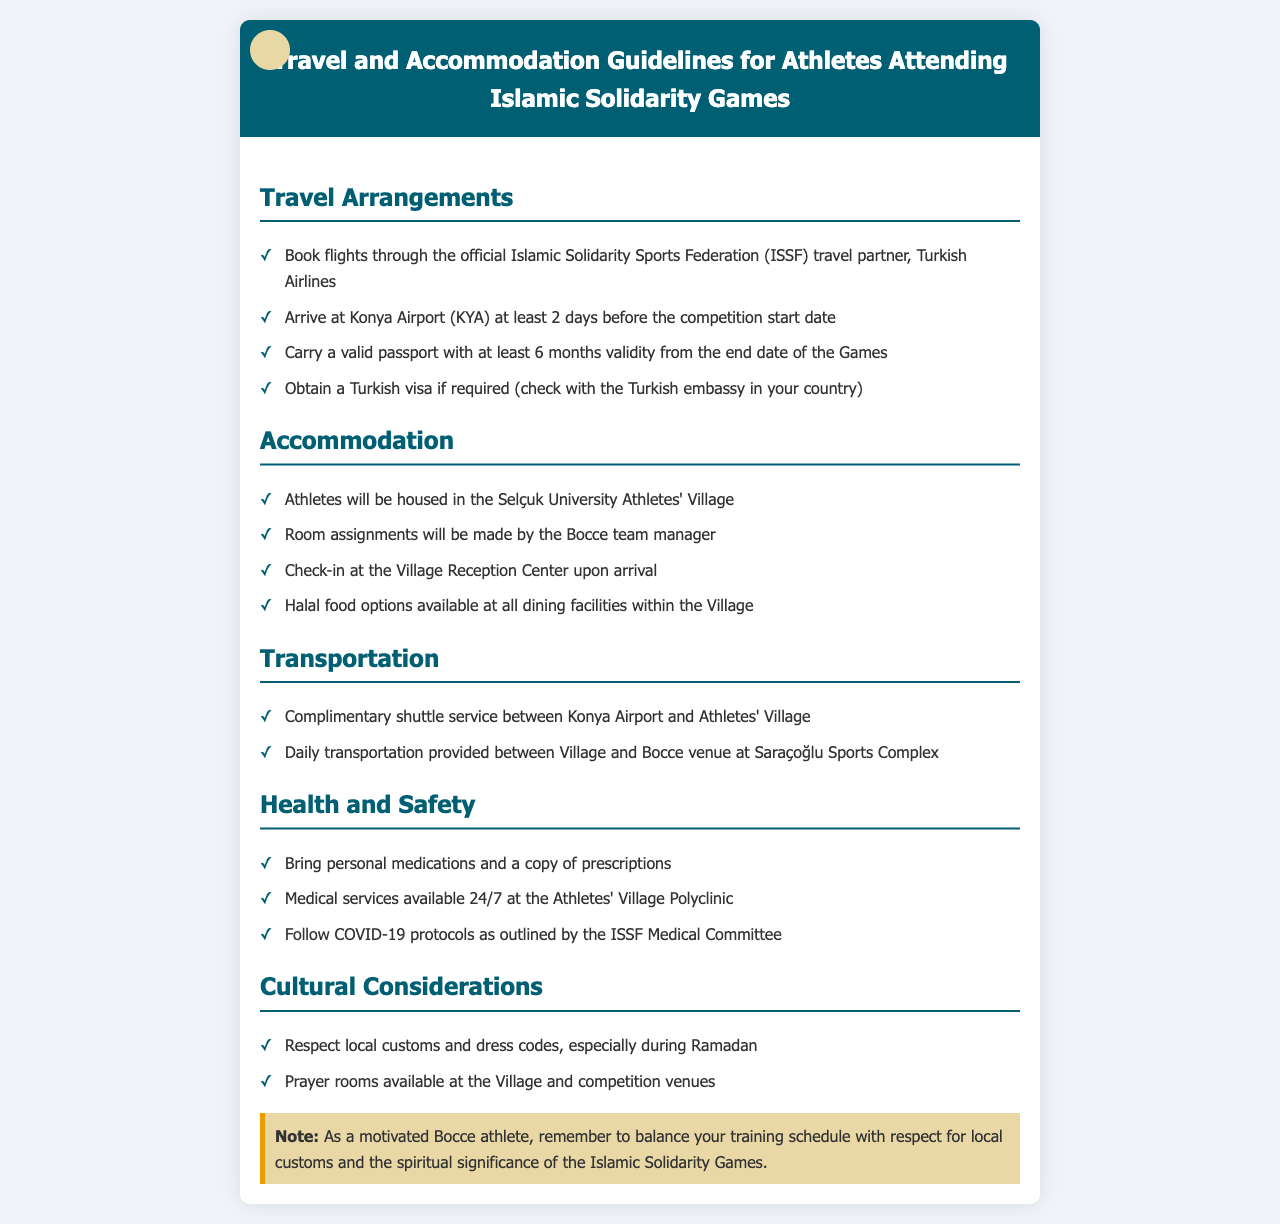What is the official travel partner for booking flights? The official travel partner for booking flights is Turkish Airlines.
Answer: Turkish Airlines How many days before the competition should athletes arrive? Athletes should arrive at least 2 days before the competition start date.
Answer: 2 days Where will athletes be housed during the Games? Athletes will be housed in the Selçuk University Athletes' Village.
Answer: Selçuk University Athletes' Village What type of food options are available at the Athletes' Village? Halal food options are available at all dining facilities within the Village.
Answer: Halal food What medical services are available at the Athletes' Village? Medical services available 24/7 at the Athletes' Village Polyclinic.
Answer: 24/7 What should athletes bring regarding medications? Athletes should bring personal medications and a copy of prescriptions.
Answer: Personal medications Which customs should athletes respect during Ramadan? Athletes should respect local customs and dress codes, especially during Ramadan.
Answer: Local customs Is there shuttle service provided for athletes? Yes, complimentary shuttle service between Konya Airport and Athletes' Village.
Answer: Complimentary shuttle service What type of transportation is provided daily? Daily transportation is provided between Village and Bocce venue at Saraçoğlu Sports Complex.
Answer: Village and Bocce venue What is an important consideration for athletes regarding their training schedule? Athletes should balance their training schedule with respect for local customs.
Answer: Local customs 